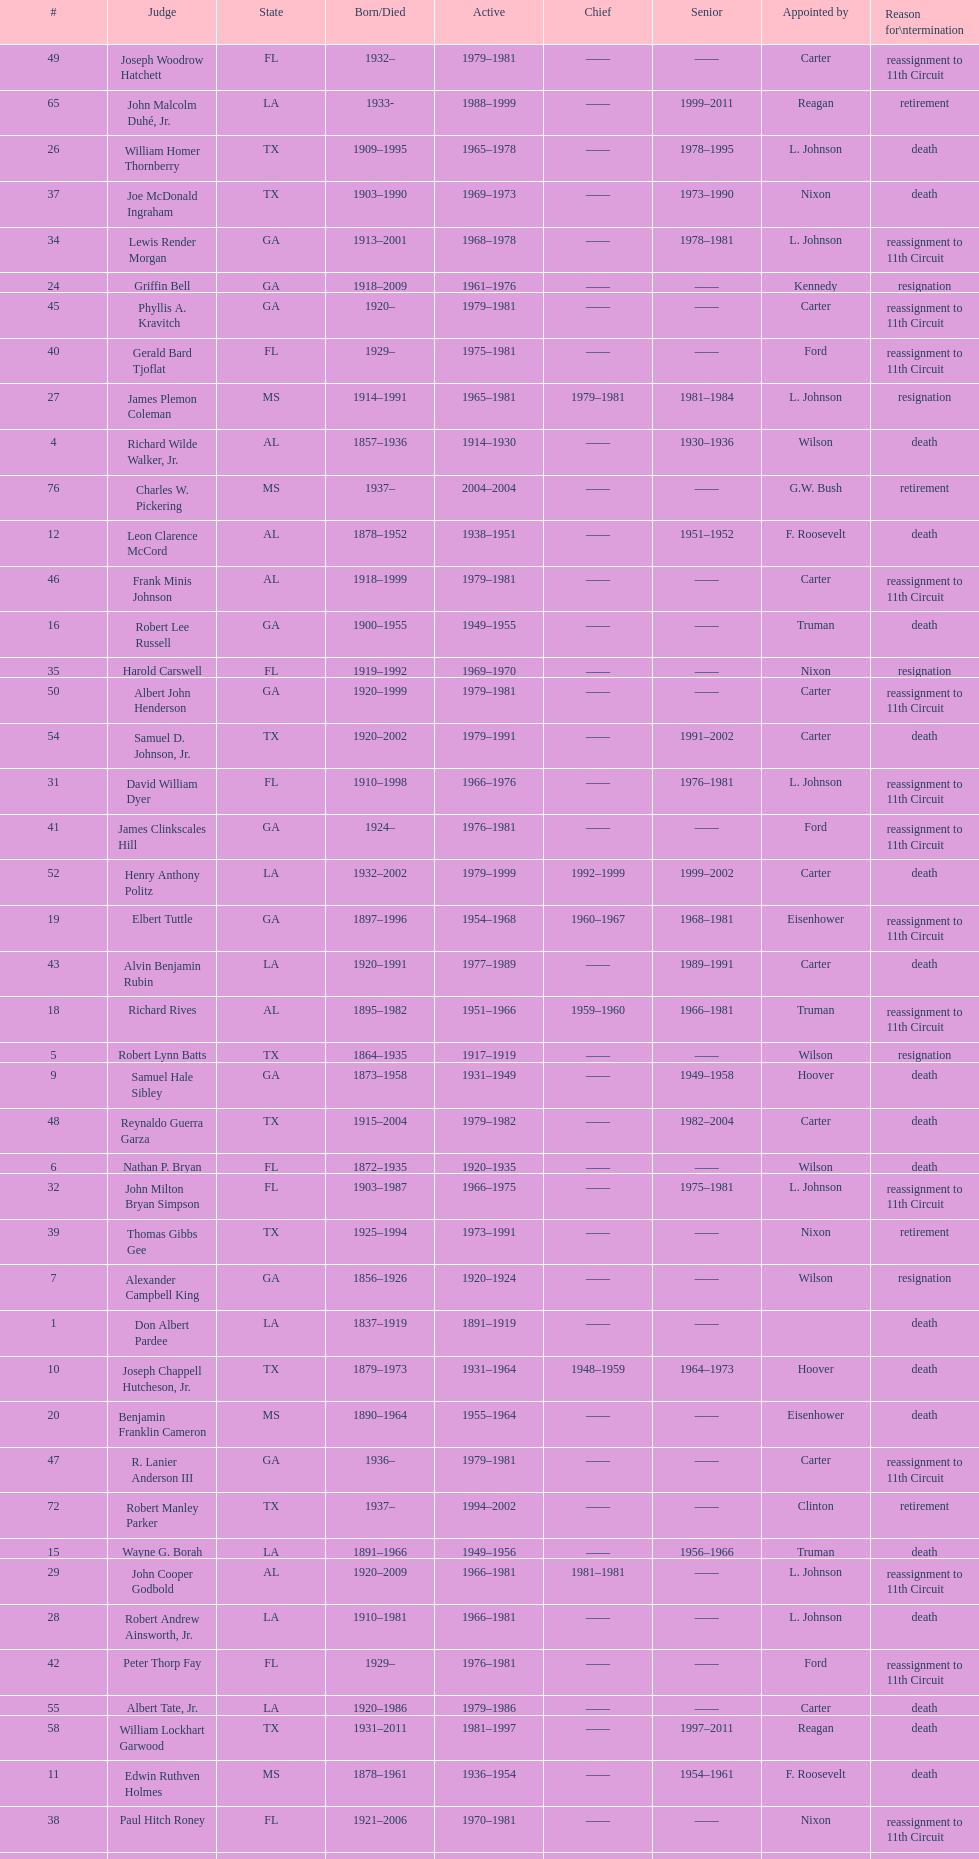How many judges served as chief total? 8. 